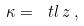Convert formula to latex. <formula><loc_0><loc_0><loc_500><loc_500>\kappa = \ t l \, z \, ,</formula> 